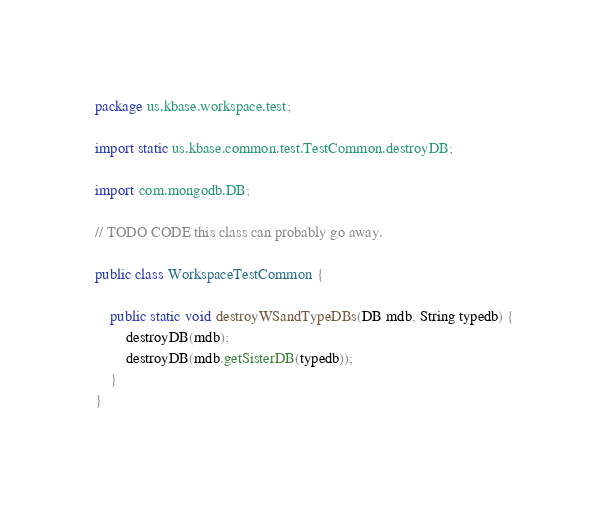<code> <loc_0><loc_0><loc_500><loc_500><_Java_>package us.kbase.workspace.test;

import static us.kbase.common.test.TestCommon.destroyDB;

import com.mongodb.DB;

// TODO CODE this class can probably go away.

public class WorkspaceTestCommon {
	
	public static void destroyWSandTypeDBs(DB mdb, String typedb) {
		destroyDB(mdb);
		destroyDB(mdb.getSisterDB(typedb));
	}
}
</code> 